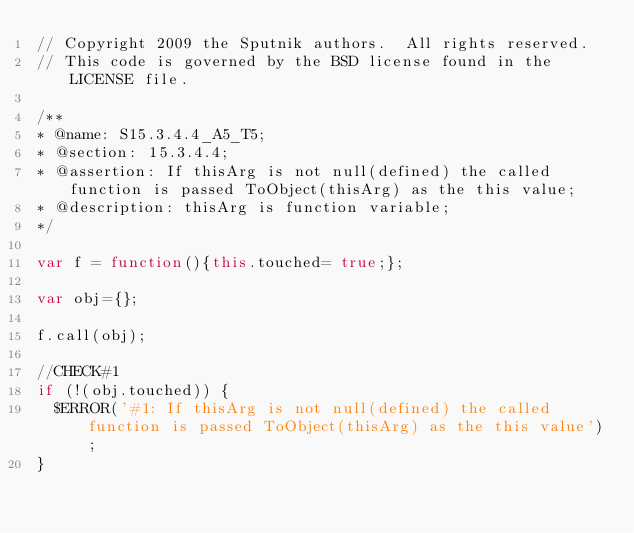Convert code to text. <code><loc_0><loc_0><loc_500><loc_500><_JavaScript_>// Copyright 2009 the Sputnik authors.  All rights reserved.
// This code is governed by the BSD license found in the LICENSE file.

/**
* @name: S15.3.4.4_A5_T5;
* @section: 15.3.4.4;
* @assertion: If thisArg is not null(defined) the called function is passed ToObject(thisArg) as the this value;
* @description: thisArg is function variable;
*/

var f = function(){this.touched= true;};

var obj={};

f.call(obj);

//CHECK#1
if (!(obj.touched)) {
  $ERROR('#1: If thisArg is not null(defined) the called function is passed ToObject(thisArg) as the this value');
}
</code> 